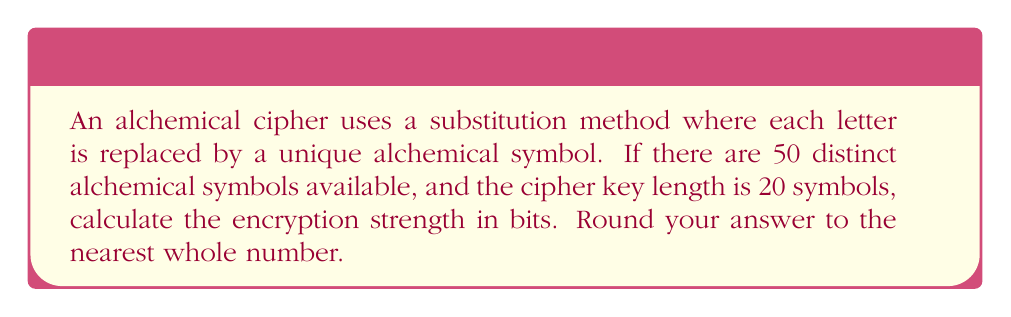Solve this math problem. To calculate the encryption strength in bits, we need to determine the number of possible keys and then express this as a power of 2.

Step 1: Calculate the number of possible keys
The number of possible keys is the number of ways to arrange 20 symbols from a set of 50 symbols. This is a permutation with repetition allowed:

$$ \text{Number of possible keys} = 50^{20} $$

Step 2: Express the number of possible keys as a power of 2
Let $x$ be the encryption strength in bits. Then:

$$ 2^x = 50^{20} $$

Step 3: Take the logarithm of both sides
$$ \log_2(2^x) = \log_2(50^{20}) $$
$$ x = 20 \log_2(50) $$

Step 4: Calculate the result
Using a calculator or logarithm tables:

$$ x = 20 \times 5.64385618977472 $$
$$ x = 112.8771237954944 $$

Step 5: Round to the nearest whole number
$$ x \approx 113 $$

Therefore, the encryption strength of the alchemical cipher is approximately 113 bits.
Answer: 113 bits 